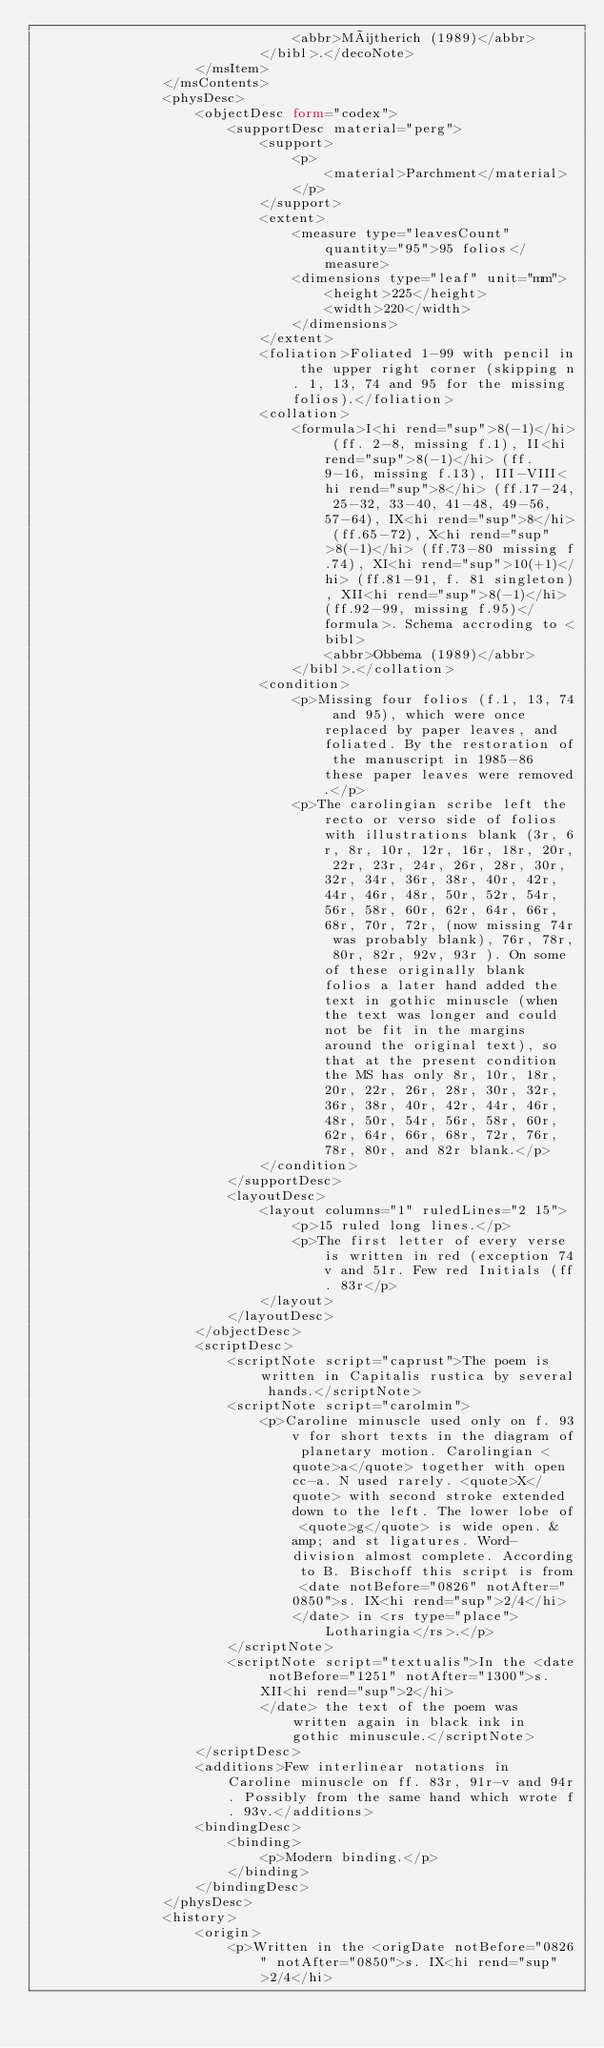<code> <loc_0><loc_0><loc_500><loc_500><_XML_>                                <abbr>Mütherich (1989)</abbr>
                            </bibl>.</decoNote>
                    </msItem>
                </msContents>
                <physDesc>
                    <objectDesc form="codex">
                        <supportDesc material="perg">
                            <support>
                                <p>
                                    <material>Parchment</material>
                                </p>
                            </support>
                            <extent>
                                <measure type="leavesCount" quantity="95">95 folios</measure>
                                <dimensions type="leaf" unit="mm">
                                    <height>225</height>
                                    <width>220</width>
                                </dimensions>
                            </extent>
                            <foliation>Foliated 1-99 with pencil in the upper right corner (skipping n. 1, 13, 74 and 95 for the missing folios).</foliation>
                            <collation>
                                <formula>I<hi rend="sup">8(-1)</hi> (ff. 2-8, missing f.1), II<hi rend="sup">8(-1)</hi> (ff. 9-16, missing f.13), III-VIII<hi rend="sup">8</hi> (ff.17-24, 25-32, 33-40, 41-48, 49-56, 57-64), IX<hi rend="sup">8</hi> (ff.65-72), X<hi rend="sup">8(-1)</hi> (ff.73-80 missing f.74), XI<hi rend="sup">10(+1)</hi> (ff.81-91, f. 81 singleton), XII<hi rend="sup">8(-1)</hi> (ff.92-99, missing f.95)</formula>. Schema accroding to <bibl>
                                    <abbr>Obbema (1989)</abbr>
                                </bibl>.</collation>
                            <condition>
                                <p>Missing four folios (f.1, 13, 74 and 95), which were once replaced by paper leaves, and foliated. By the restoration of the manuscript in 1985-86 these paper leaves were removed.</p>
                                <p>The carolingian scribe left the recto or verso side of folios with illustrations blank (3r, 6r, 8r, 10r, 12r, 16r, 18r, 20r, 22r, 23r, 24r, 26r, 28r, 30r, 32r, 34r, 36r, 38r, 40r, 42r, 44r, 46r, 48r, 50r, 52r, 54r, 56r, 58r, 60r, 62r, 64r, 66r, 68r, 70r, 72r, (now missing 74r was probably blank), 76r, 78r, 80r, 82r, 92v, 93r ). On some of these originally blank folios a later hand added the text in gothic minuscle (when the text was longer and could not be fit in the margins around the original text), so that at the present condition the MS has only 8r, 10r, 18r, 20r, 22r, 26r, 28r, 30r, 32r, 36r, 38r, 40r, 42r, 44r, 46r, 48r, 50r, 54r, 56r, 58r, 60r, 62r, 64r, 66r, 68r, 72r, 76r, 78r, 80r, and 82r blank.</p>
                            </condition>
                        </supportDesc>
                        <layoutDesc>
                            <layout columns="1" ruledLines="2 15">
                                <p>15 ruled long lines.</p>
                                <p>The first letter of every verse is written in red (exception 74v and 51r. Few red Initials (ff. 83r</p>
                            </layout>
                        </layoutDesc>
                    </objectDesc>
                    <scriptDesc>
                        <scriptNote script="caprust">The poem is written in Capitalis rustica by several hands.</scriptNote>
                        <scriptNote script="carolmin">
                            <p>Caroline minuscle used only on f. 93v for short texts in the diagram of planetary motion. Carolingian <quote>a</quote> together with open cc-a. N used rarely. <quote>X</quote> with second stroke extended down to the left. The lower lobe of <quote>g</quote> is wide open. &amp; and st ligatures. Word-division almost complete. According to B. Bischoff this script is from <date notBefore="0826" notAfter="0850">s. IX<hi rend="sup">2/4</hi>
                                </date> in <rs type="place">Lotharingia</rs>.</p>
                        </scriptNote>
                        <scriptNote script="textualis">In the <date notBefore="1251" notAfter="1300">s. XII<hi rend="sup">2</hi>
                            </date> the text of the poem was written again in black ink in gothic minuscule.</scriptNote>
                    </scriptDesc>
                    <additions>Few interlinear notations in Caroline minuscle on ff. 83r, 91r-v and 94r. Possibly from the same hand which wrote f. 93v.</additions>
                    <bindingDesc>
                        <binding>
                            <p>Modern binding.</p>
                        </binding>
                    </bindingDesc>
                </physDesc>
                <history>
                    <origin>
                        <p>Written in the <origDate notBefore="0826" notAfter="0850">s. IX<hi rend="sup">2/4</hi></code> 